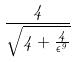Convert formula to latex. <formula><loc_0><loc_0><loc_500><loc_500>\frac { 4 } { \sqrt { 4 + \frac { 4 } { \epsilon ^ { 9 } } } }</formula> 